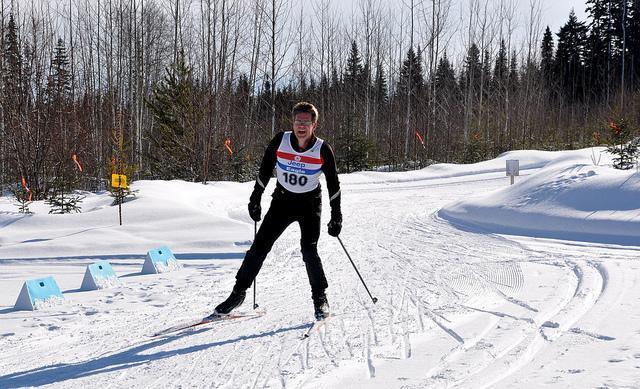How many elephants in this photo?
Give a very brief answer. 0. 